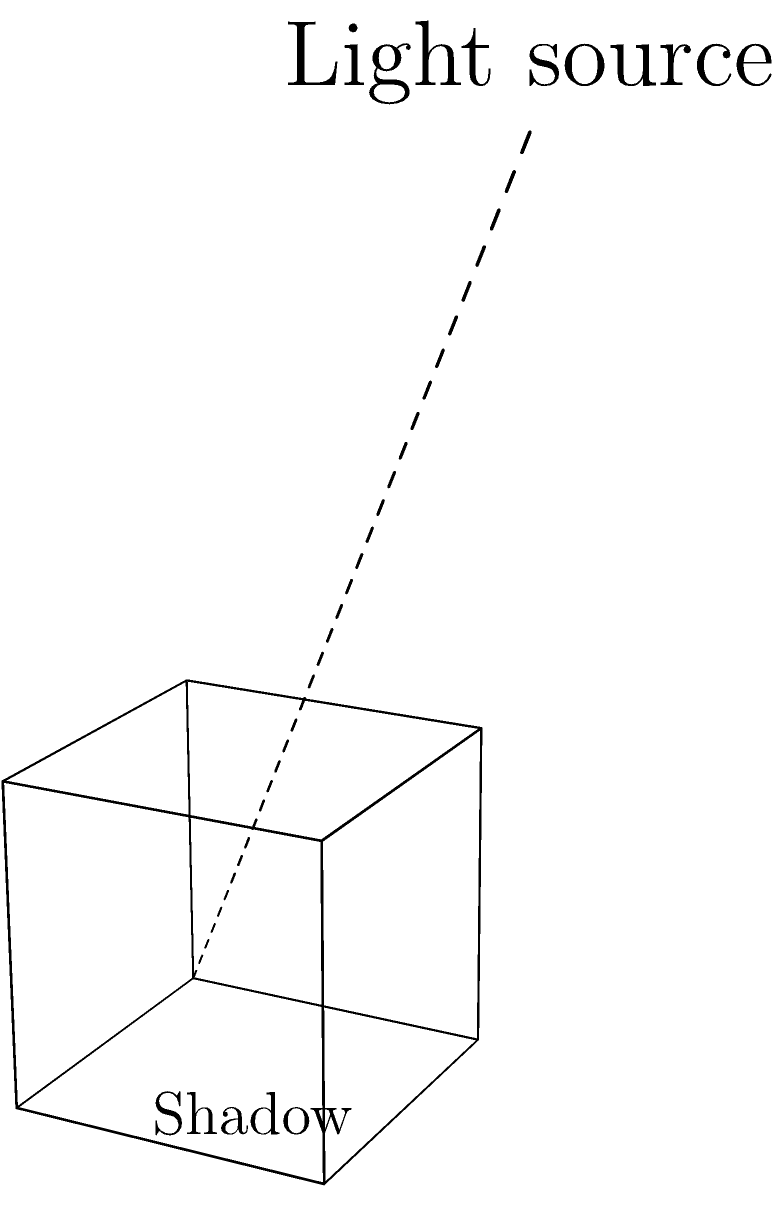In the context of visualizing mood shifts in a script through shadow play, consider a cube illuminated by a single light source as shown in the diagram. If the light source is moved directly above the cube, how would this affect the shadow's shape and what emotional tone might this convey in your artistic interpretation? To understand the shadow's transformation and its emotional implications, let's follow these steps:

1. Current light position: The light source is positioned diagonally above and to the side of the cube, creating an elongated shadow.

2. New light position: Moving the light source directly above the cube.

3. Shadow transformation:
   a. The shadow will shrink significantly.
   b. It will become a perfect square, directly beneath the cube.
   c. The shadow's edges will become sharper and more defined.

4. Artistic interpretation:
   a. Shrinking shadow: Could symbolize a reduction in the character's influence or presence in the story.
   b. Perfect square shape: Might represent stability, order, or a moment of clarity in the script.
   c. Sharp edges: Could indicate a decisive moment or a clear-cut situation in the narrative.

5. Emotional tone:
   a. The transition from an elongated, distorted shadow to a compact, symmetrical one might suggest a shift from uncertainty or complexity to clarity and resolution.
   b. The directness of the overhead light could symbolize revelation, truth, or a moment of epiphany in the script.
   c. The stark contrast between light and shadow might convey a sense of finality or absoluteness in the story's progression.

This transformation in lighting and shadow can be used to visually represent a character's journey from confusion to understanding, or a plot's movement from complexity to resolution.
Answer: Shrinking square shadow; clarity and resolution 